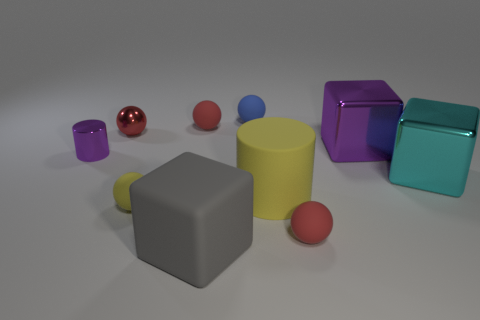What number of things are cyan metal objects that are on the right side of the yellow matte ball or big blocks that are in front of the yellow sphere?
Offer a very short reply. 2. What shape is the purple thing that is the same size as the blue ball?
Provide a short and direct response. Cylinder. The gray cube that is made of the same material as the big yellow cylinder is what size?
Provide a short and direct response. Large. Does the small yellow thing have the same shape as the cyan metallic thing?
Offer a very short reply. No. The cylinder that is the same size as the cyan object is what color?
Provide a short and direct response. Yellow. The cyan shiny object that is the same shape as the gray thing is what size?
Your answer should be compact. Large. What shape is the red object in front of the cyan object?
Ensure brevity in your answer.  Sphere. Is the shape of the big cyan thing the same as the tiny shiny object that is on the left side of the tiny red shiny object?
Your answer should be compact. No. Are there an equal number of matte balls that are in front of the yellow matte ball and big blocks that are behind the big yellow rubber thing?
Offer a very short reply. No. The object that is the same color as the large rubber cylinder is what shape?
Your answer should be compact. Sphere. 